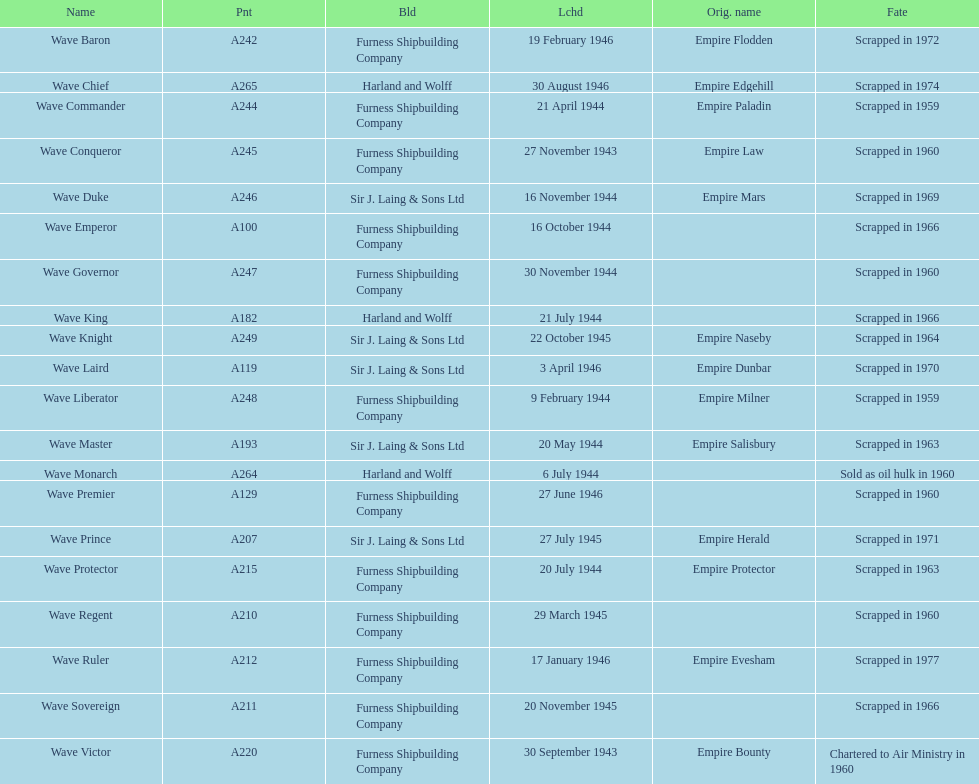How many ships were launched in the year 1944? 9. 